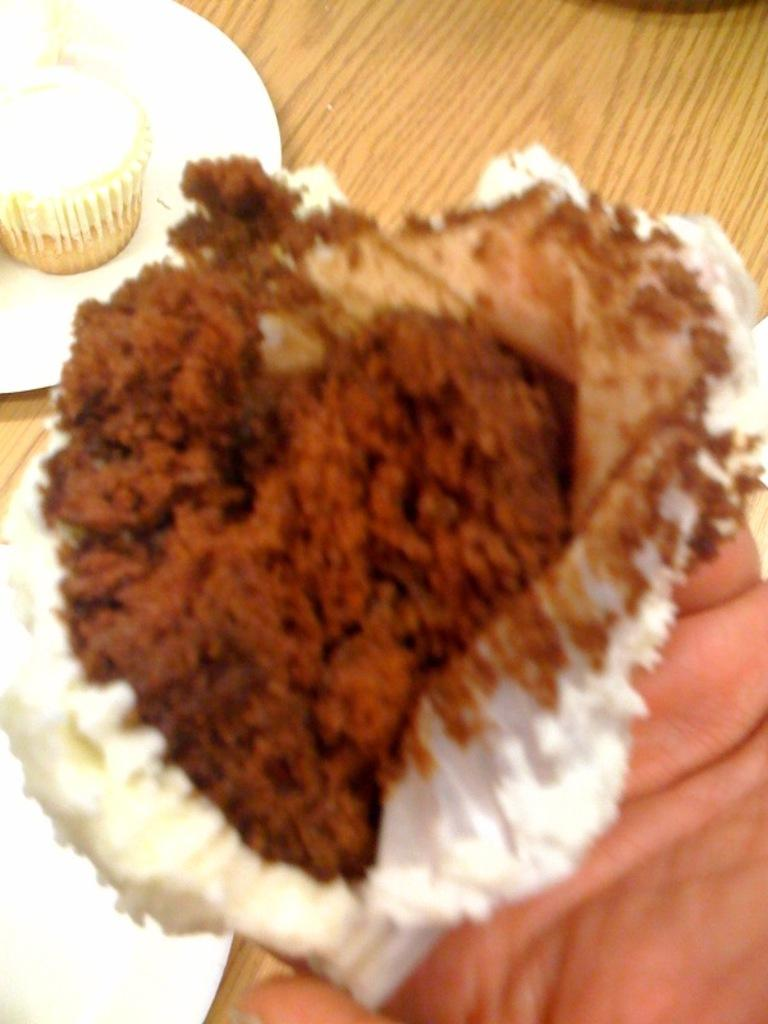What is the person holding in the image? There is a hand holding a cupcake in the image. Can you describe the background of the image? There is a plate containing a cupcake and an empty plate on a wooden table in the background. How many cupcakes are visible in the image? There are two cupcakes visible in the image, one being held by a hand and the other on a plate in the background. What health benefits does the invention in the image provide? There is no invention present in the image, so it is not possible to discuss its health benefits. 